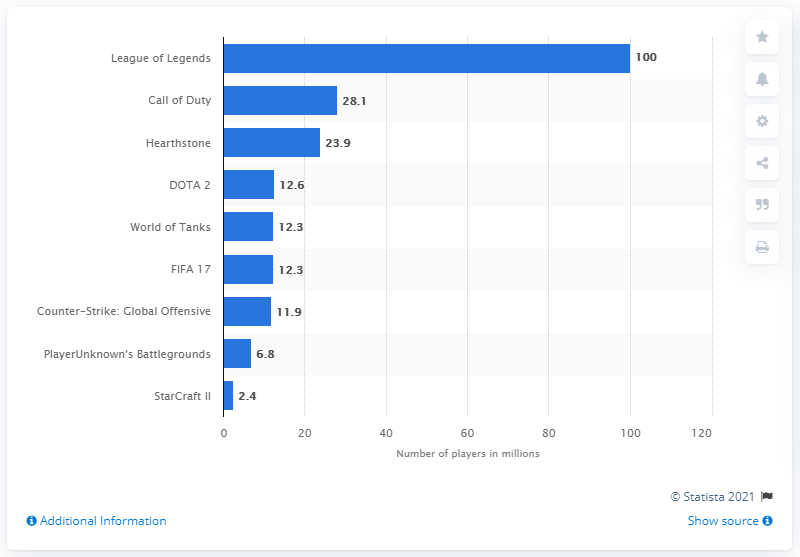Highlight a few significant elements in this photo. World of Tanks ranked fifth in the measured period with 12.3 million players. League of Legends was the leader among games in terms of the number of eSports players, demonstrating its popularity and widespread recognition in the competitive gaming community. During the presented period, there were approximately 100 players actively playing League of Legends. 